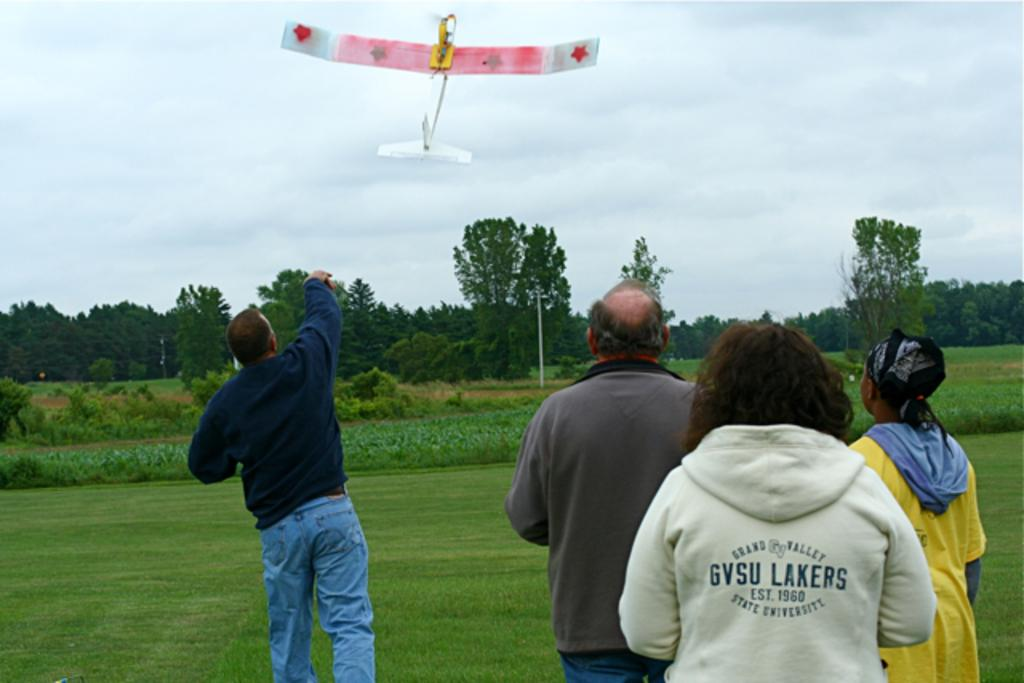<image>
Render a clear and concise summary of the photo. A woman in a sweater with the words Grand Valley at the top watching a man throw a toy plane. 